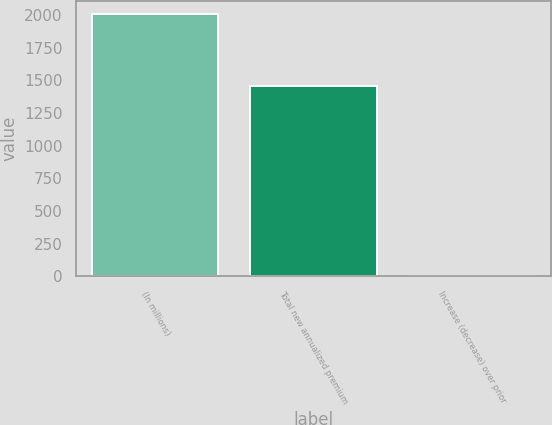Convert chart. <chart><loc_0><loc_0><loc_500><loc_500><bar_chart><fcel>(In millions)<fcel>Total new annualized premium<fcel>Increase (decrease) over prior<nl><fcel>2009<fcel>1453<fcel>6.4<nl></chart> 